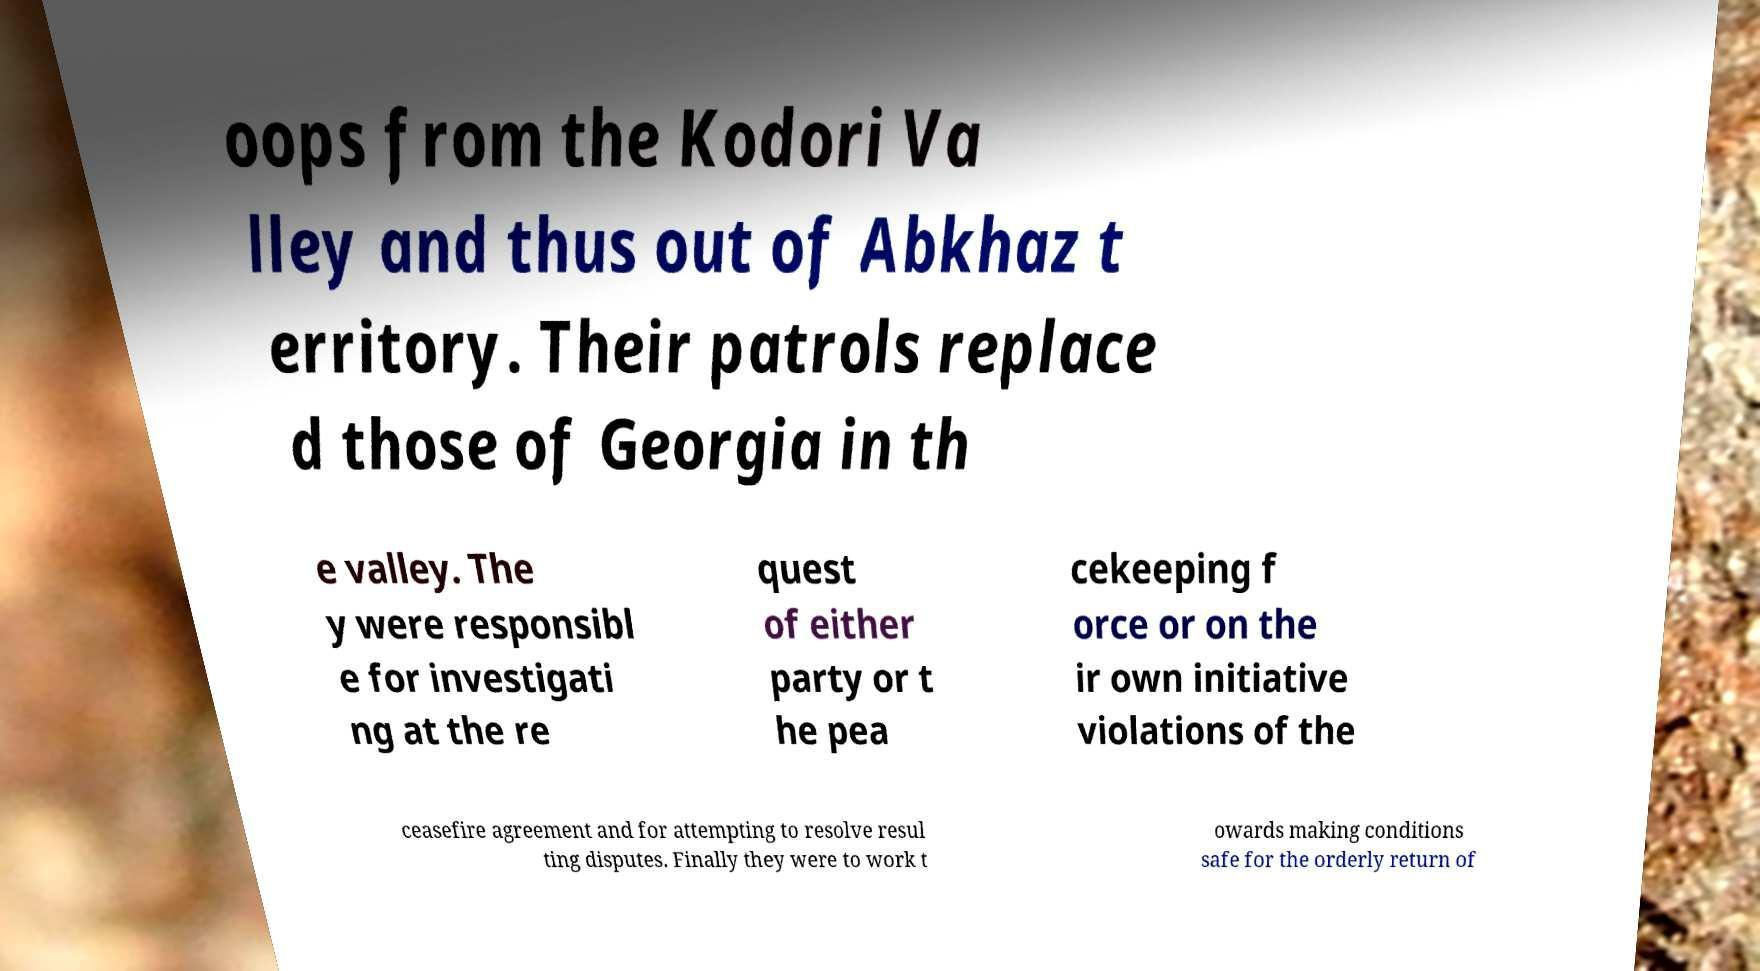For documentation purposes, I need the text within this image transcribed. Could you provide that? oops from the Kodori Va lley and thus out of Abkhaz t erritory. Their patrols replace d those of Georgia in th e valley. The y were responsibl e for investigati ng at the re quest of either party or t he pea cekeeping f orce or on the ir own initiative violations of the ceasefire agreement and for attempting to resolve resul ting disputes. Finally they were to work t owards making conditions safe for the orderly return of 